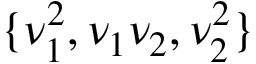Convert formula to latex. <formula><loc_0><loc_0><loc_500><loc_500>\{ \nu _ { 1 } ^ { 2 } , \nu _ { 1 } \nu _ { 2 } , \nu _ { 2 } ^ { 2 } \}</formula> 